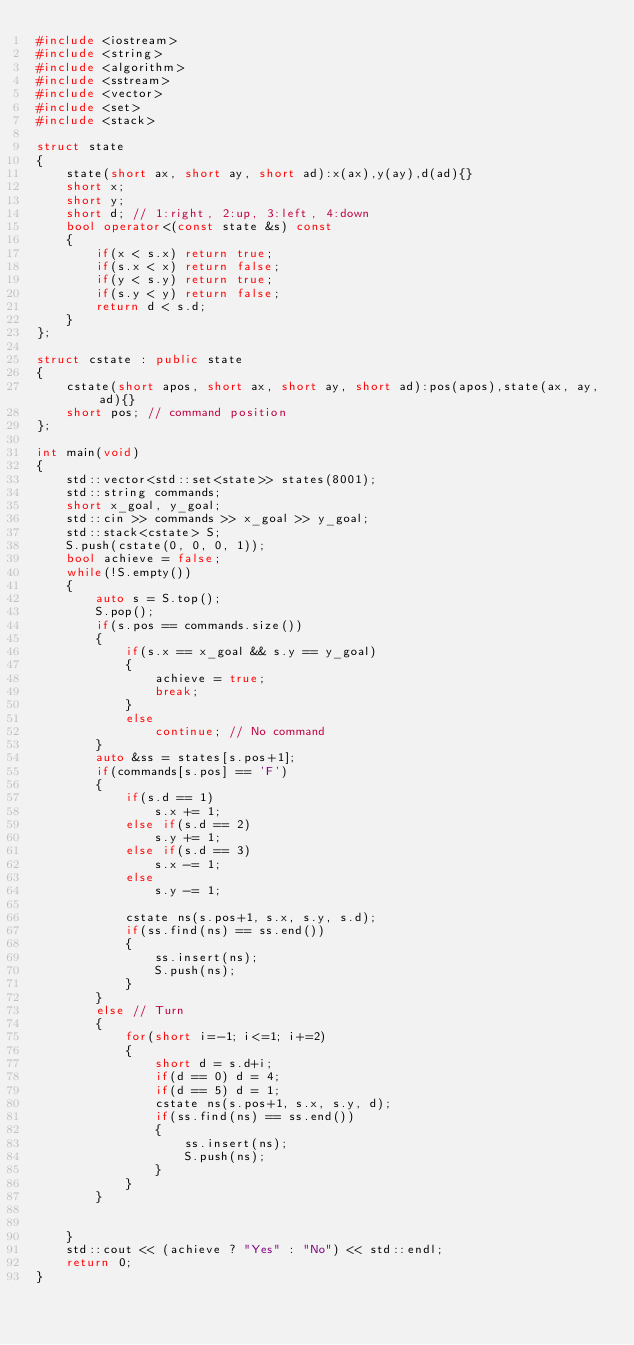<code> <loc_0><loc_0><loc_500><loc_500><_C++_>#include <iostream>
#include <string>
#include <algorithm>
#include <sstream>
#include <vector>
#include <set>
#include <stack>

struct state
{
    state(short ax, short ay, short ad):x(ax),y(ay),d(ad){}
    short x;
    short y;
    short d; // 1:right, 2:up, 3:left, 4:down
    bool operator<(const state &s) const
    {
        if(x < s.x) return true;
        if(s.x < x) return false;
        if(y < s.y) return true;
        if(s.y < y) return false;
        return d < s.d;
    }
};

struct cstate : public state
{
    cstate(short apos, short ax, short ay, short ad):pos(apos),state(ax, ay, ad){}
    short pos; // command position
};

int main(void)
{
    std::vector<std::set<state>> states(8001);
    std::string commands;
    short x_goal, y_goal;
    std::cin >> commands >> x_goal >> y_goal;
    std::stack<cstate> S;
    S.push(cstate(0, 0, 0, 1));
    bool achieve = false;
    while(!S.empty())
    {
        auto s = S.top();
        S.pop();
        if(s.pos == commands.size())
        {
            if(s.x == x_goal && s.y == y_goal)
            {
                achieve = true;
                break;
            }
            else
                continue; // No command
        }
        auto &ss = states[s.pos+1];
        if(commands[s.pos] == 'F')
        {
            if(s.d == 1)
                s.x += 1;
            else if(s.d == 2)
                s.y += 1;
            else if(s.d == 3)
                s.x -= 1;
            else
                s.y -= 1;
            
            cstate ns(s.pos+1, s.x, s.y, s.d);
            if(ss.find(ns) == ss.end())
            {
                ss.insert(ns);
                S.push(ns);
            }
        }
        else // Turn
        {
            for(short i=-1; i<=1; i+=2)
            {
                short d = s.d+i;
                if(d == 0) d = 4;
                if(d == 5) d = 1;
                cstate ns(s.pos+1, s.x, s.y, d);
                if(ss.find(ns) == ss.end())
                {
                    ss.insert(ns);
                    S.push(ns);
                }
            }
        }
        

    }
    std::cout << (achieve ? "Yes" : "No") << std::endl;
    return 0;
}
</code> 